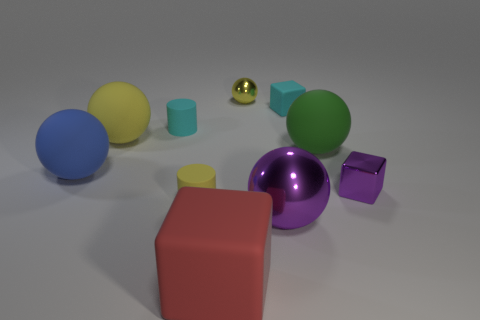Subtract all green balls. How many balls are left? 4 Subtract all purple spheres. How many spheres are left? 4 Subtract 2 balls. How many balls are left? 3 Subtract all gray balls. Subtract all red cylinders. How many balls are left? 5 Subtract all blocks. How many objects are left? 7 Subtract 1 yellow cylinders. How many objects are left? 9 Subtract all cyan cubes. Subtract all matte spheres. How many objects are left? 6 Add 7 yellow matte spheres. How many yellow matte spheres are left? 8 Add 1 small gray rubber blocks. How many small gray rubber blocks exist? 1 